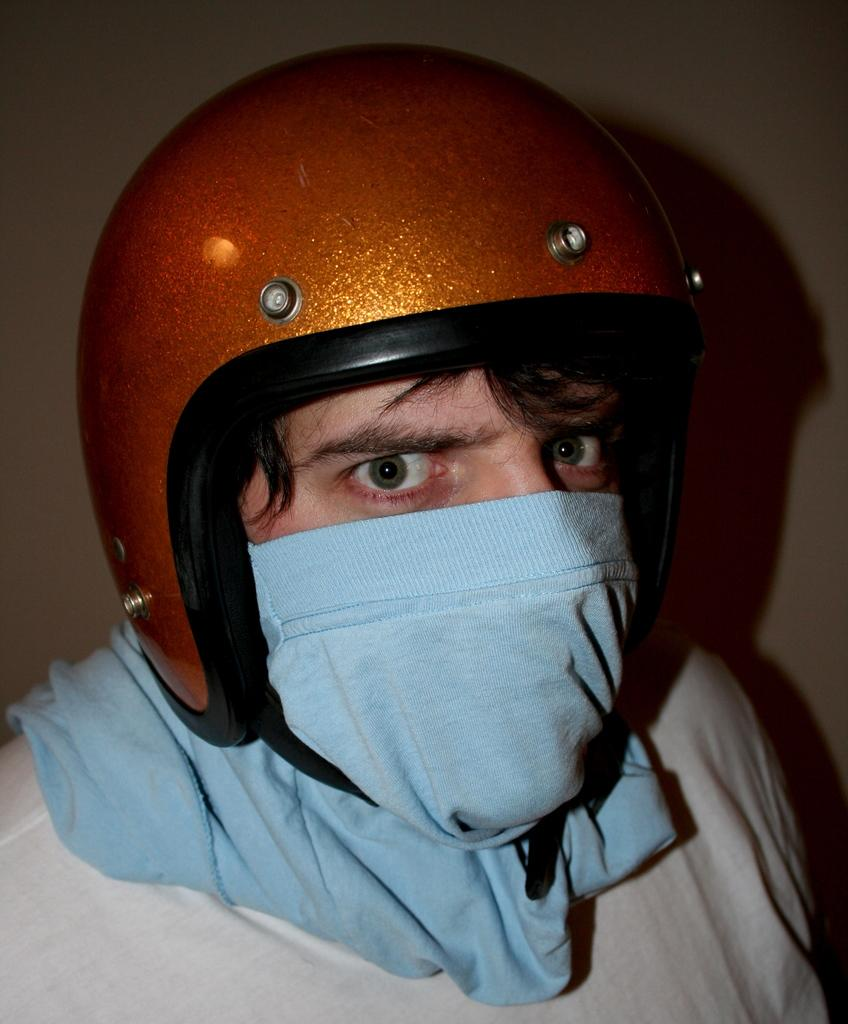Who is present in the image? There is a man in the image. What is the man wearing on his head? The man is wearing a helmet. What is the man wearing on his face? The man is wearing a mask. What can be seen in the background of the image? There is a wall in the background of the image. What type of straw is the man holding in the image? There is no straw present in the image. How does the man's heart rate appear to be in the image? There is no indication of the man's heart rate in the image. 